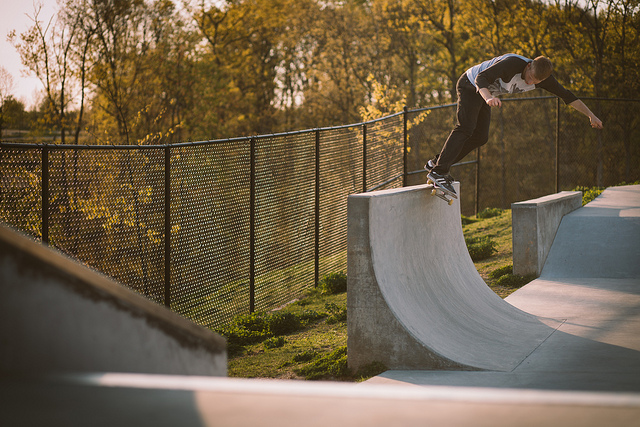What kind of skateboarding move is being performed? The skateboarder appears to be performing a grind, where one slides along an edge or surface on the trucks of the skateboard. Is it a safe environment for skateboarding? From the image, the environment looks specifically designed for skateboarding, with smooth concrete surfaces and safety-oriented design, suggesting a safe place for the sport. 